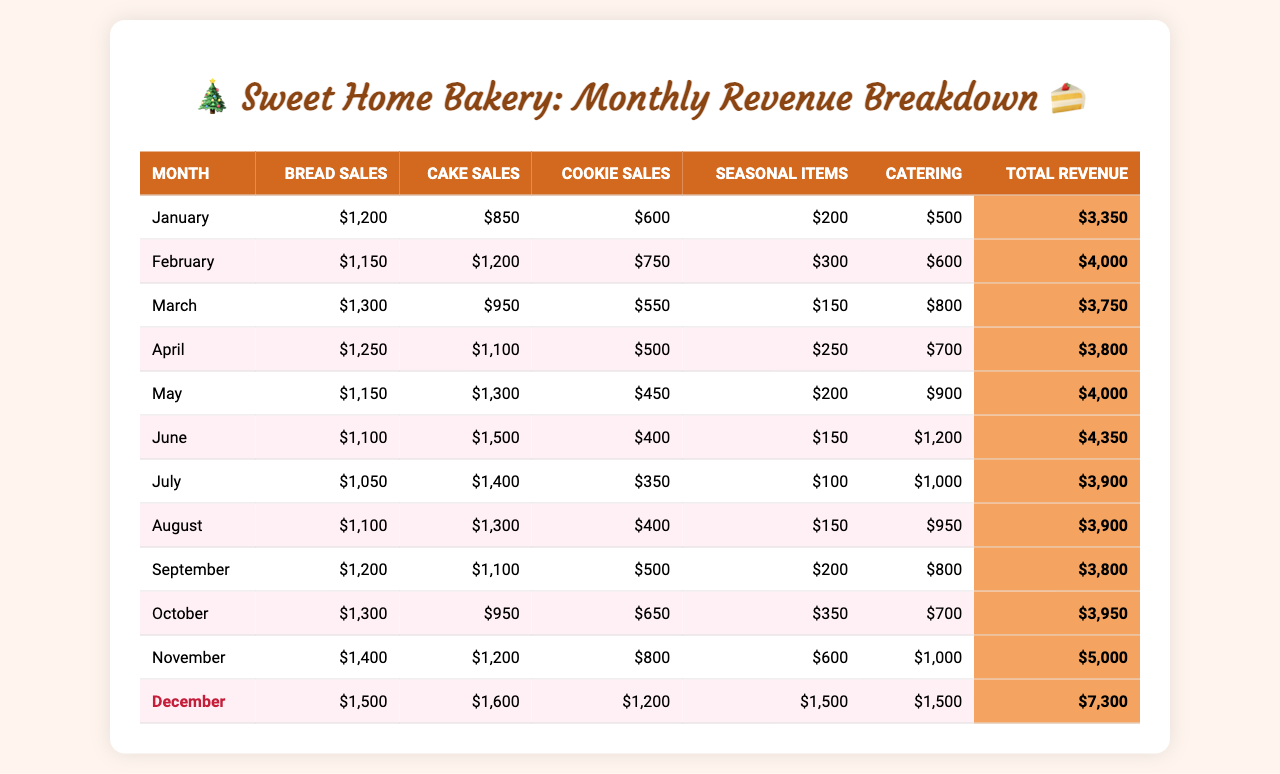What's the total revenue for December? In the "Total Revenue" column for December, the value is listed as 7300.
Answer: 7300 Which month had the highest cake sales? By comparing the cake sales across months, December shows the highest value of 1600.
Answer: December What is the average revenue for the months from January to June? Calculate the total revenue from January to June: 3350 + 4000 + 3750 + 3800 + 4000 + 4350 = 22650, then divide by 6 (months) giving 22650/6 = 3775.
Answer: 3775 Did catering revenue increase every month from January to December? Upon inspecting the catering revenue column, some months show decreases (e.g., March to April), indicating that it's not an increase every month.
Answer: No What is the revenue difference between the highest and lowest month in catering sales? The highest catering sales are in December (1500) and the lowest are in January (500). The difference is calculated as 1500 - 500 = 1000.
Answer: 1000 In which month did cookie sales reach their lowest point, and what was the amount? By looking at the cookie sales amounts, May shows the lowest value of 450.
Answer: May, 450 What was the total revenue for the year? To find the total revenue for the year, sum up all the monthly total revenues: 3350 + 4000 + 3750 + 3800 + 4000 + 4350 + 3900 + 3900 + 3800 + 3950 + 5000 + 7300 = 47400.
Answer: 47400 Which month had the most sales of seasonal items, and how much were they? December had the highest sales for seasonal items, listed as 1500 in that month.
Answer: December, 1500 How much more revenue was generated from bread sales in December compared to January? Bread sales in December totaled 1500 and in January totaled 1200. Calculating the difference gives 1500 - 1200 = 300.
Answer: 300 What percentage of the total revenue in November comes from cake sales? The total revenue for November is 5000, and cake sales are 1200. Therefore, the percentage is (1200/5000) * 100 = 24%.
Answer: 24% 